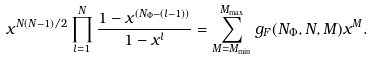Convert formula to latex. <formula><loc_0><loc_0><loc_500><loc_500>x ^ { N ( N - 1 ) / 2 } \prod _ { l = 1 } ^ { N } \frac { 1 - x ^ { ( N _ { \Phi } - ( l - 1 ) ) } } { 1 - x ^ { l } } = \sum _ { M = M _ { \min } } ^ { M _ { \max } } g _ { F } ( N _ { \Phi } , N , M ) x ^ { M } .</formula> 